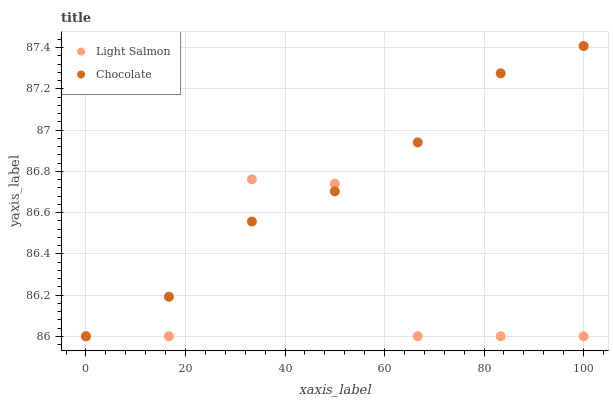Does Light Salmon have the minimum area under the curve?
Answer yes or no. Yes. Does Chocolate have the maximum area under the curve?
Answer yes or no. Yes. Does Chocolate have the minimum area under the curve?
Answer yes or no. No. Is Chocolate the smoothest?
Answer yes or no. Yes. Is Light Salmon the roughest?
Answer yes or no. Yes. Is Chocolate the roughest?
Answer yes or no. No. Does Light Salmon have the lowest value?
Answer yes or no. Yes. Does Chocolate have the highest value?
Answer yes or no. Yes. Does Chocolate intersect Light Salmon?
Answer yes or no. Yes. Is Chocolate less than Light Salmon?
Answer yes or no. No. Is Chocolate greater than Light Salmon?
Answer yes or no. No. 